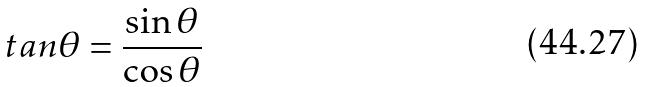<formula> <loc_0><loc_0><loc_500><loc_500>t a n \theta = \frac { \sin \theta } { \cos \theta }</formula> 